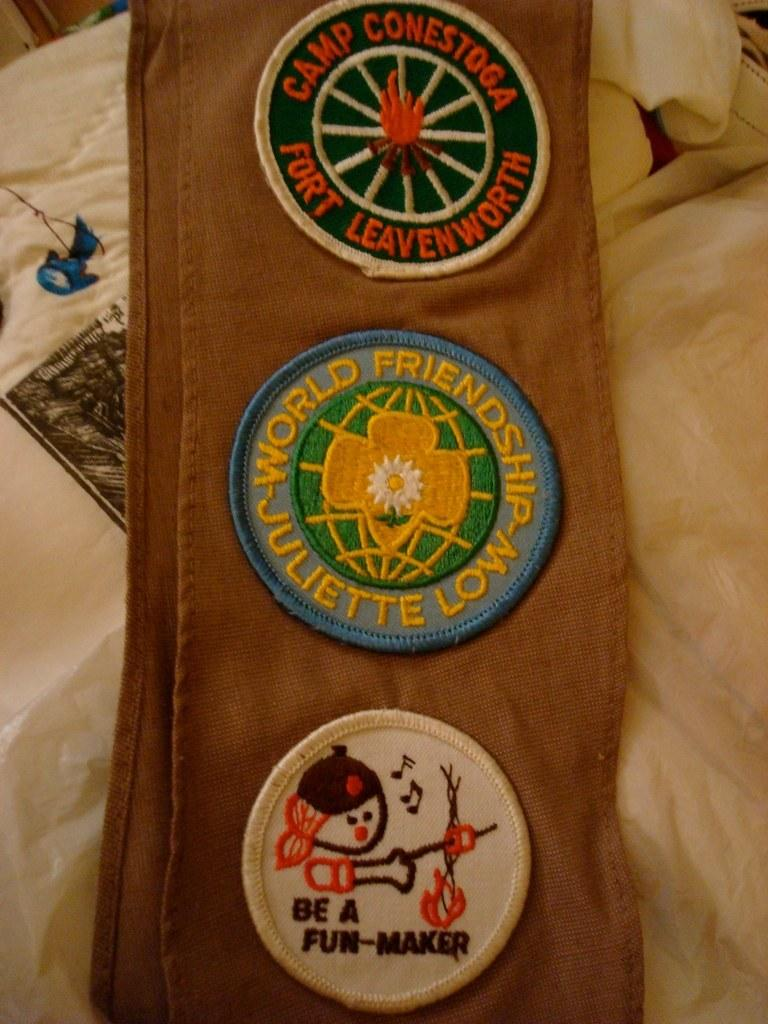What is stitched to the brown color cloth in the image? There are badges stitched to the brown color cloth in the image. What is the brown color cloth placed on in the image? The brown color cloth is on a cream color bed sheet. What is the color and pattern of the object visible in the image? The object visible in the image is blue and black in color. What songs can be heard playing in the background of the image? There is no mention of songs or any audio element in the image, so it is not possible to determine what songs might be heard. 